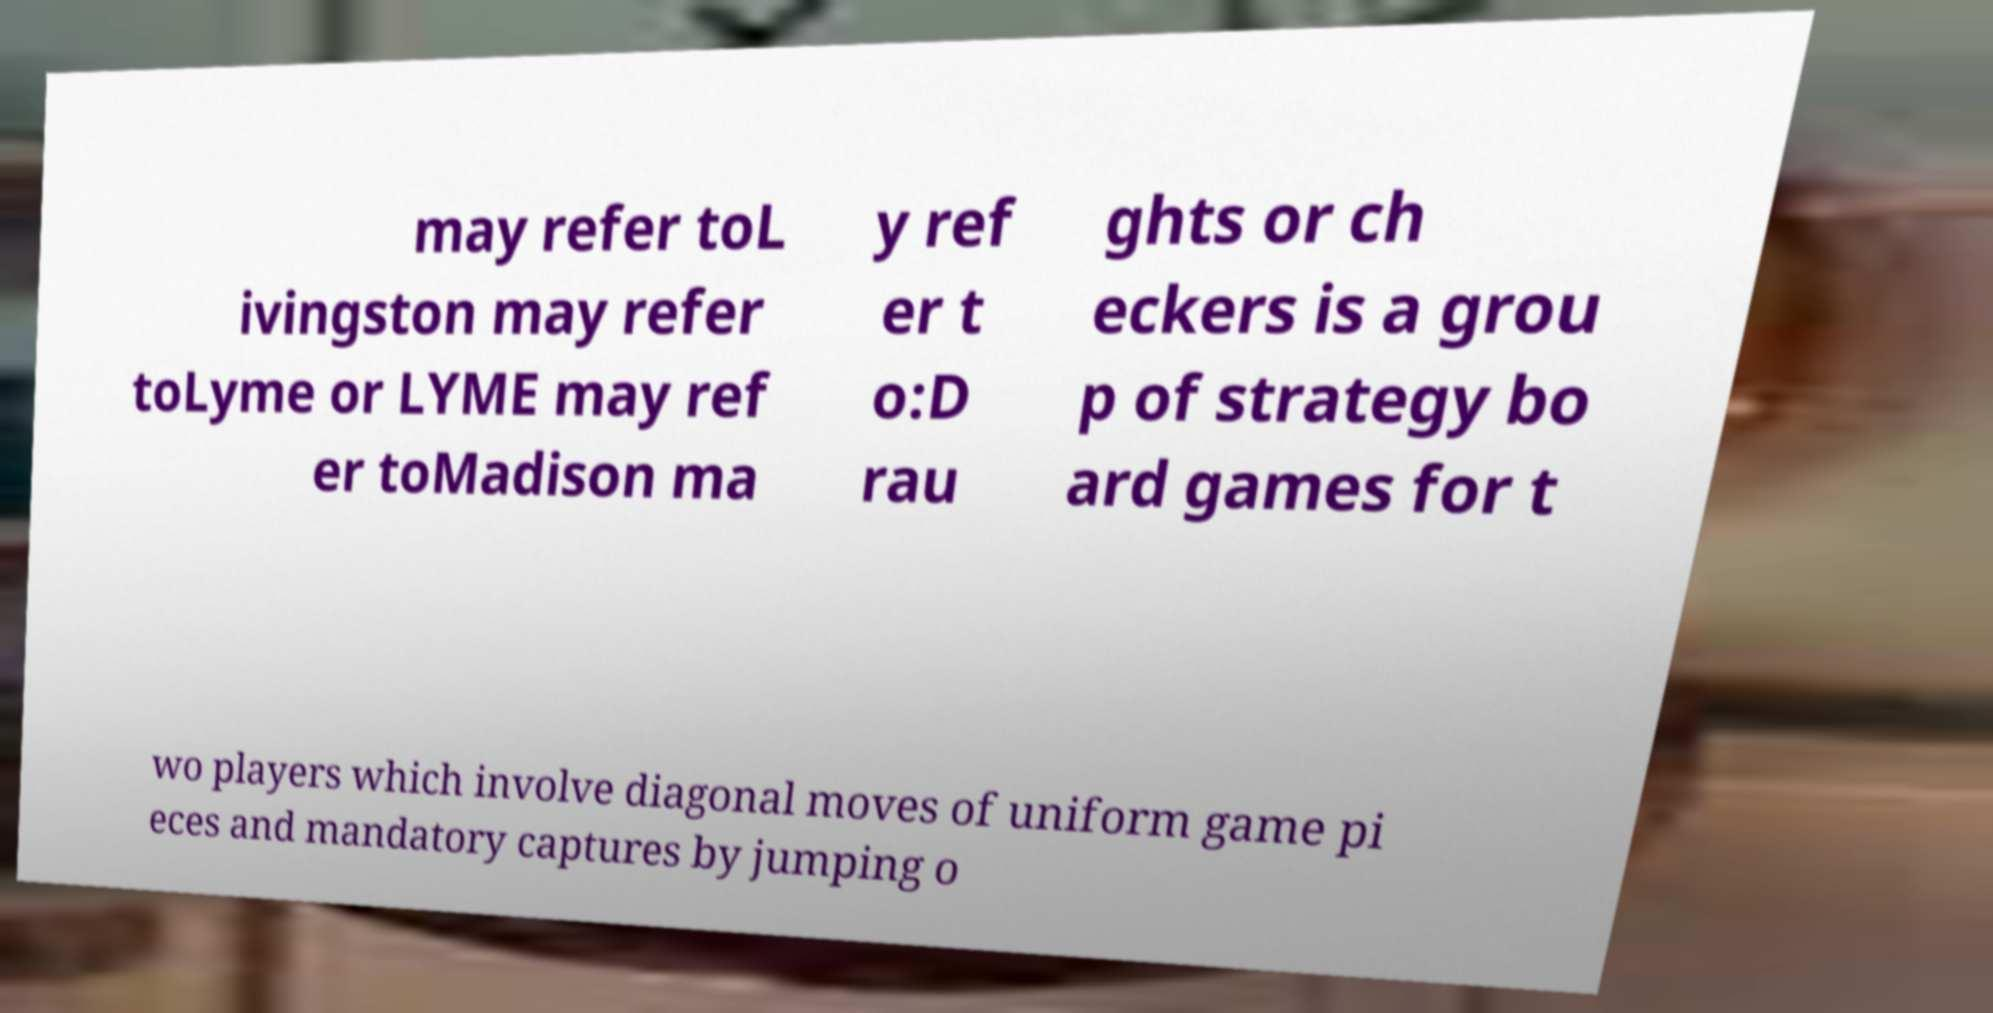Please identify and transcribe the text found in this image. may refer toL ivingston may refer toLyme or LYME may ref er toMadison ma y ref er t o:D rau ghts or ch eckers is a grou p of strategy bo ard games for t wo players which involve diagonal moves of uniform game pi eces and mandatory captures by jumping o 